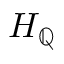Convert formula to latex. <formula><loc_0><loc_0><loc_500><loc_500>H _ { \mathbb { Q } }</formula> 